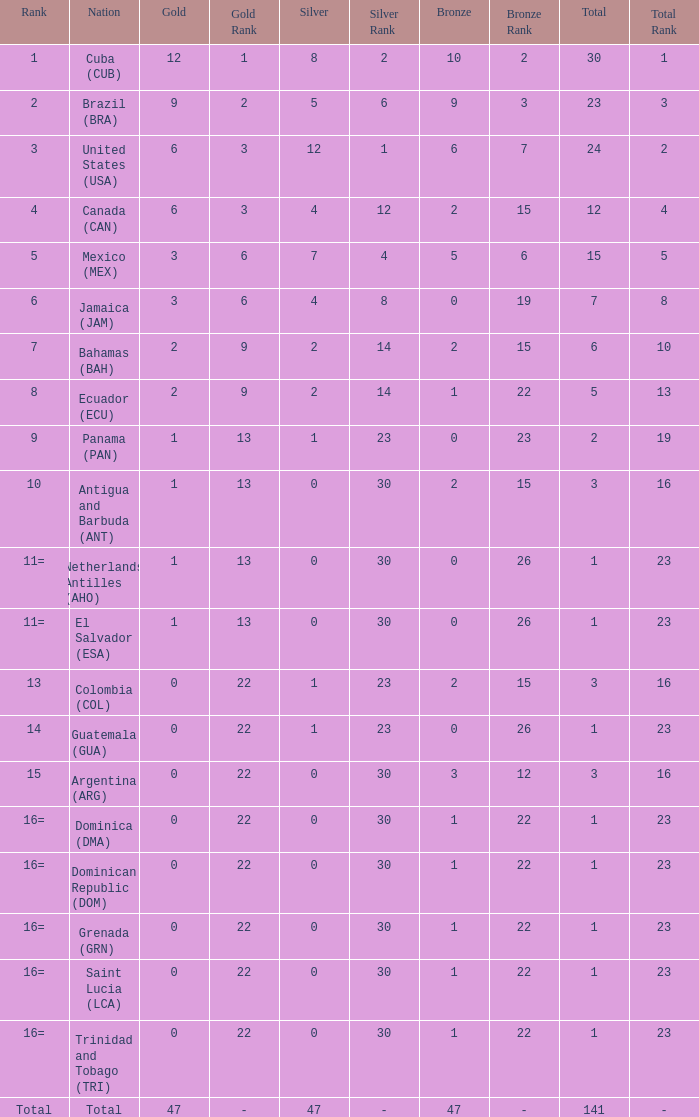Parse the table in full. {'header': ['Rank', 'Nation', 'Gold', 'Gold Rank', 'Silver', 'Silver Rank', 'Bronze', 'Bronze Rank', 'Total', 'Total Rank'], 'rows': [['1', 'Cuba (CUB)', '12', '1', '8', '2', '10', '2', '30', '1'], ['2', 'Brazil (BRA)', '9', '2', '5', '6', '9', '3', '23', '3'], ['3', 'United States (USA)', '6', '3', '12', '1', '6', '7', '24', '2'], ['4', 'Canada (CAN)', '6', '3', '4', '12', '2', '15', '12', '4'], ['5', 'Mexico (MEX)', '3', '6', '7', '4', '5', '6', '15', '5'], ['6', 'Jamaica (JAM)', '3', '6', '4', '8', '0', '19', '7', '8'], ['7', 'Bahamas (BAH)', '2', '9', '2', '14', '2', '15', '6', '10'], ['8', 'Ecuador (ECU)', '2', '9', '2', '14', '1', '22', '5', '13'], ['9', 'Panama (PAN)', '1', '13', '1', '23', '0', '23', '2', '19'], ['10', 'Antigua and Barbuda (ANT)', '1', '13', '0', '30', '2', '15', '3', '16'], ['11=', 'Netherlands Antilles (AHO)', '1', '13', '0', '30', '0', '26', '1', '23'], ['11=', 'El Salvador (ESA)', '1', '13', '0', '30', '0', '26', '1', '23'], ['13', 'Colombia (COL)', '0', '22', '1', '23', '2', '15', '3', '16'], ['14', 'Guatemala (GUA)', '0', '22', '1', '23', '0', '26', '1', '23'], ['15', 'Argentina (ARG)', '0', '22', '0', '30', '3', '12', '3', '16'], ['16=', 'Dominica (DMA)', '0', '22', '0', '30', '1', '22', '1', '23'], ['16=', 'Dominican Republic (DOM)', '0', '22', '0', '30', '1', '22', '1', '23'], ['16=', 'Grenada (GRN)', '0', '22', '0', '30', '1', '22', '1', '23'], ['16=', 'Saint Lucia (LCA)', '0', '22', '0', '30', '1', '22', '1', '23'], ['16=', 'Trinidad and Tobago (TRI)', '0', '22', '0', '30', '1', '22', '1', '23'], ['Total', 'Total', '47', '-', '47', '-', '47', '-', '141', '-']]} What is the total gold with a total less than 1? None. 